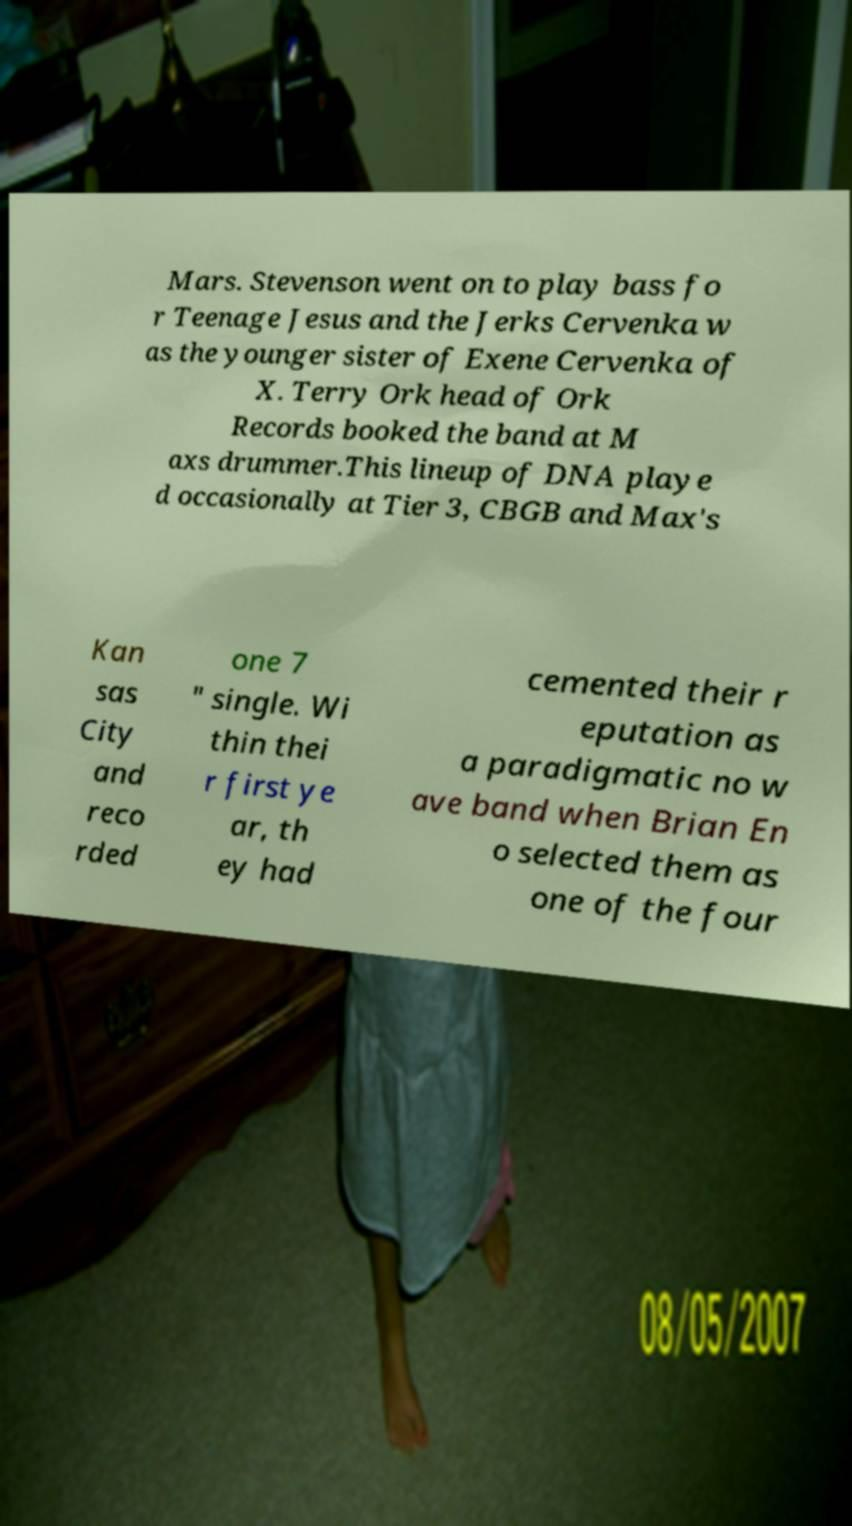Please identify and transcribe the text found in this image. Mars. Stevenson went on to play bass fo r Teenage Jesus and the Jerks Cervenka w as the younger sister of Exene Cervenka of X. Terry Ork head of Ork Records booked the band at M axs drummer.This lineup of DNA playe d occasionally at Tier 3, CBGB and Max's Kan sas City and reco rded one 7 " single. Wi thin thei r first ye ar, th ey had cemented their r eputation as a paradigmatic no w ave band when Brian En o selected them as one of the four 